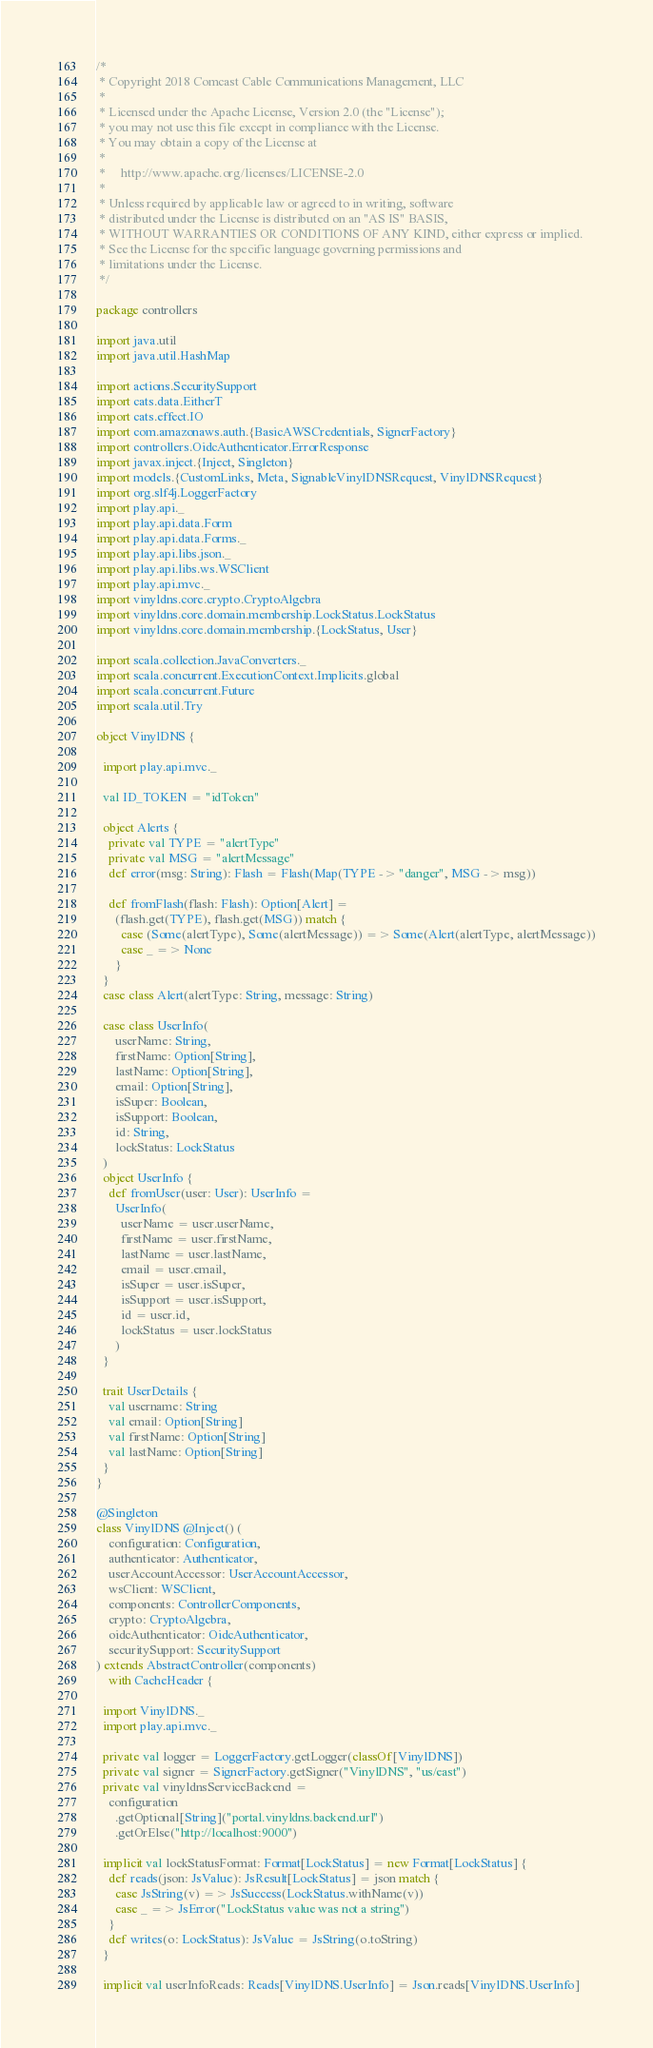Convert code to text. <code><loc_0><loc_0><loc_500><loc_500><_Scala_>/*
 * Copyright 2018 Comcast Cable Communications Management, LLC
 *
 * Licensed under the Apache License, Version 2.0 (the "License");
 * you may not use this file except in compliance with the License.
 * You may obtain a copy of the License at
 *
 *     http://www.apache.org/licenses/LICENSE-2.0
 *
 * Unless required by applicable law or agreed to in writing, software
 * distributed under the License is distributed on an "AS IS" BASIS,
 * WITHOUT WARRANTIES OR CONDITIONS OF ANY KIND, either express or implied.
 * See the License for the specific language governing permissions and
 * limitations under the License.
 */

package controllers

import java.util
import java.util.HashMap

import actions.SecuritySupport
import cats.data.EitherT
import cats.effect.IO
import com.amazonaws.auth.{BasicAWSCredentials, SignerFactory}
import controllers.OidcAuthenticator.ErrorResponse
import javax.inject.{Inject, Singleton}
import models.{CustomLinks, Meta, SignableVinylDNSRequest, VinylDNSRequest}
import org.slf4j.LoggerFactory
import play.api._
import play.api.data.Form
import play.api.data.Forms._
import play.api.libs.json._
import play.api.libs.ws.WSClient
import play.api.mvc._
import vinyldns.core.crypto.CryptoAlgebra
import vinyldns.core.domain.membership.LockStatus.LockStatus
import vinyldns.core.domain.membership.{LockStatus, User}

import scala.collection.JavaConverters._
import scala.concurrent.ExecutionContext.Implicits.global
import scala.concurrent.Future
import scala.util.Try

object VinylDNS {

  import play.api.mvc._

  val ID_TOKEN = "idToken"

  object Alerts {
    private val TYPE = "alertType"
    private val MSG = "alertMessage"
    def error(msg: String): Flash = Flash(Map(TYPE -> "danger", MSG -> msg))

    def fromFlash(flash: Flash): Option[Alert] =
      (flash.get(TYPE), flash.get(MSG)) match {
        case (Some(alertType), Some(alertMessage)) => Some(Alert(alertType, alertMessage))
        case _ => None
      }
  }
  case class Alert(alertType: String, message: String)

  case class UserInfo(
      userName: String,
      firstName: Option[String],
      lastName: Option[String],
      email: Option[String],
      isSuper: Boolean,
      isSupport: Boolean,
      id: String,
      lockStatus: LockStatus
  )
  object UserInfo {
    def fromUser(user: User): UserInfo =
      UserInfo(
        userName = user.userName,
        firstName = user.firstName,
        lastName = user.lastName,
        email = user.email,
        isSuper = user.isSuper,
        isSupport = user.isSupport,
        id = user.id,
        lockStatus = user.lockStatus
      )
  }

  trait UserDetails {
    val username: String
    val email: Option[String]
    val firstName: Option[String]
    val lastName: Option[String]
  }
}

@Singleton
class VinylDNS @Inject() (
    configuration: Configuration,
    authenticator: Authenticator,
    userAccountAccessor: UserAccountAccessor,
    wsClient: WSClient,
    components: ControllerComponents,
    crypto: CryptoAlgebra,
    oidcAuthenticator: OidcAuthenticator,
    securitySupport: SecuritySupport
) extends AbstractController(components)
    with CacheHeader {

  import VinylDNS._
  import play.api.mvc._

  private val logger = LoggerFactory.getLogger(classOf[VinylDNS])
  private val signer = SignerFactory.getSigner("VinylDNS", "us/east")
  private val vinyldnsServiceBackend =
    configuration
      .getOptional[String]("portal.vinyldns.backend.url")
      .getOrElse("http://localhost:9000")

  implicit val lockStatusFormat: Format[LockStatus] = new Format[LockStatus] {
    def reads(json: JsValue): JsResult[LockStatus] = json match {
      case JsString(v) => JsSuccess(LockStatus.withName(v))
      case _ => JsError("LockStatus value was not a string")
    }
    def writes(o: LockStatus): JsValue = JsString(o.toString)
  }

  implicit val userInfoReads: Reads[VinylDNS.UserInfo] = Json.reads[VinylDNS.UserInfo]</code> 